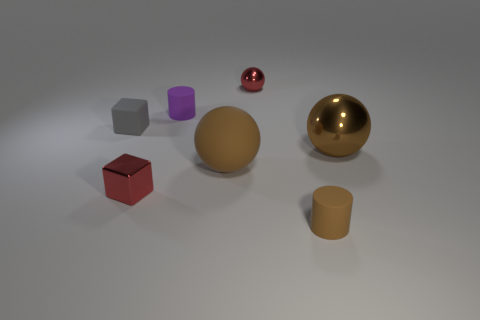Subtract all big spheres. How many spheres are left? 1 Add 3 red blocks. How many objects exist? 10 Subtract all purple cylinders. How many cylinders are left? 1 Subtract all cyan balls. How many gray cubes are left? 1 Subtract 2 cylinders. How many cylinders are left? 0 Subtract all cubes. How many objects are left? 5 Subtract all cyan spheres. Subtract all cyan cylinders. How many spheres are left? 3 Subtract all big brown objects. Subtract all tiny purple rubber cylinders. How many objects are left? 4 Add 6 large brown metal things. How many large brown metal things are left? 7 Add 5 cylinders. How many cylinders exist? 7 